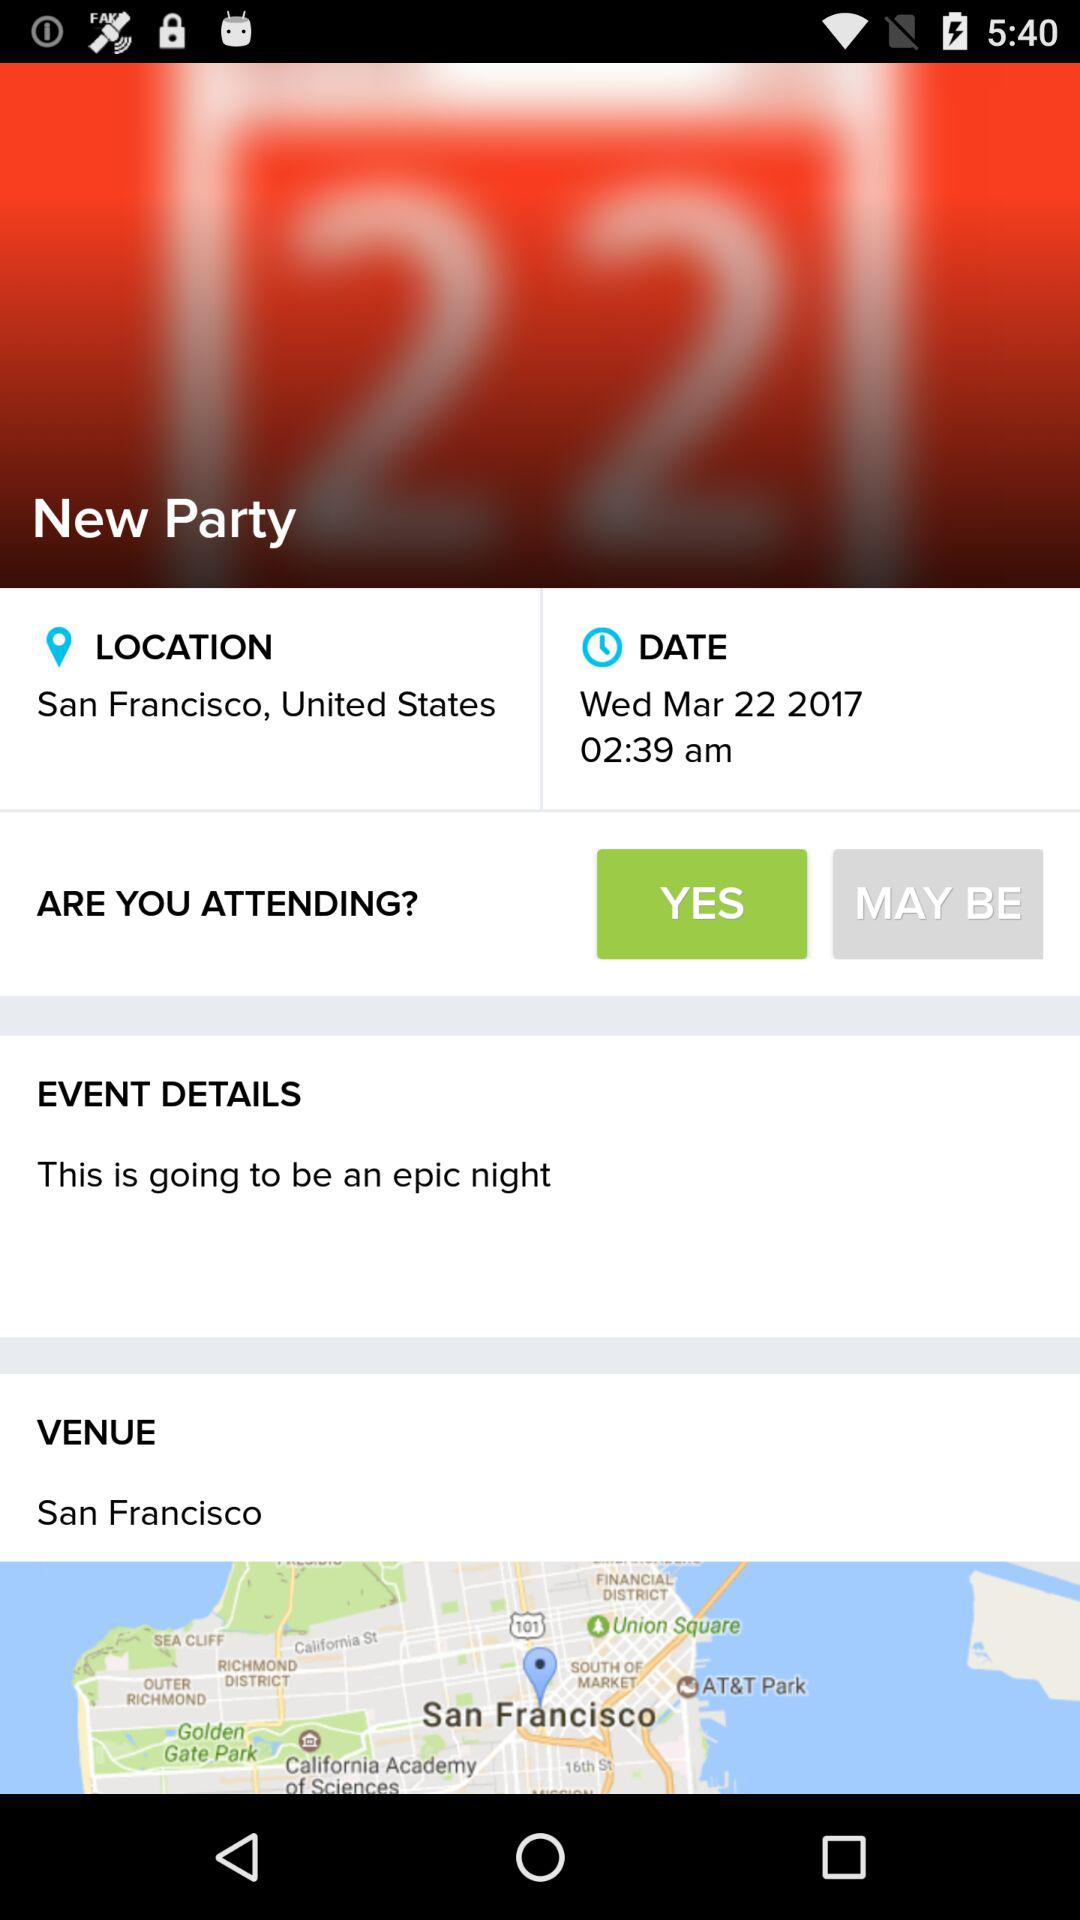What is the location? The location is San Francisco, United States. 